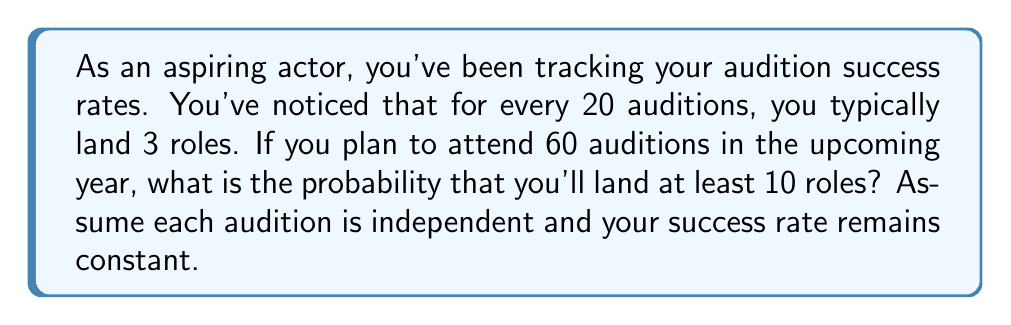Can you solve this math problem? Let's approach this step-by-step:

1) First, we need to calculate the probability of landing a role in a single audition:
   $p = \frac{3}{20} = 0.15$ or 15%

2) The probability of not landing a role in a single audition is:
   $q = 1 - p = 1 - 0.15 = 0.85$ or 85%

3) We want to find the probability of landing at least 10 roles in 60 auditions. This is equivalent to finding the probability of not landing 0 to 9 roles and subtracting it from 1.

4) This scenario follows a binomial distribution. The probability of exactly $k$ successes in $n$ trials is given by:

   $$P(X = k) = \binom{n}{k} p^k q^{n-k}$$

5) We need to sum this for $k = 0$ to $9$ and subtract from 1:

   $$P(X \geq 10) = 1 - \sum_{k=0}^9 \binom{60}{k} (0.15)^k (0.85)^{60-k}$$

6) This sum is complex to calculate by hand, so we'd typically use statistical software or a calculator with binomial probability functions. Using such a tool, we find:

   $$P(X \geq 10) \approx 0.8944$$

Therefore, the probability of landing at least 10 roles in 60 auditions is approximately 0.8944 or 89.44%.
Answer: $0.8944$ or $89.44\%$ 